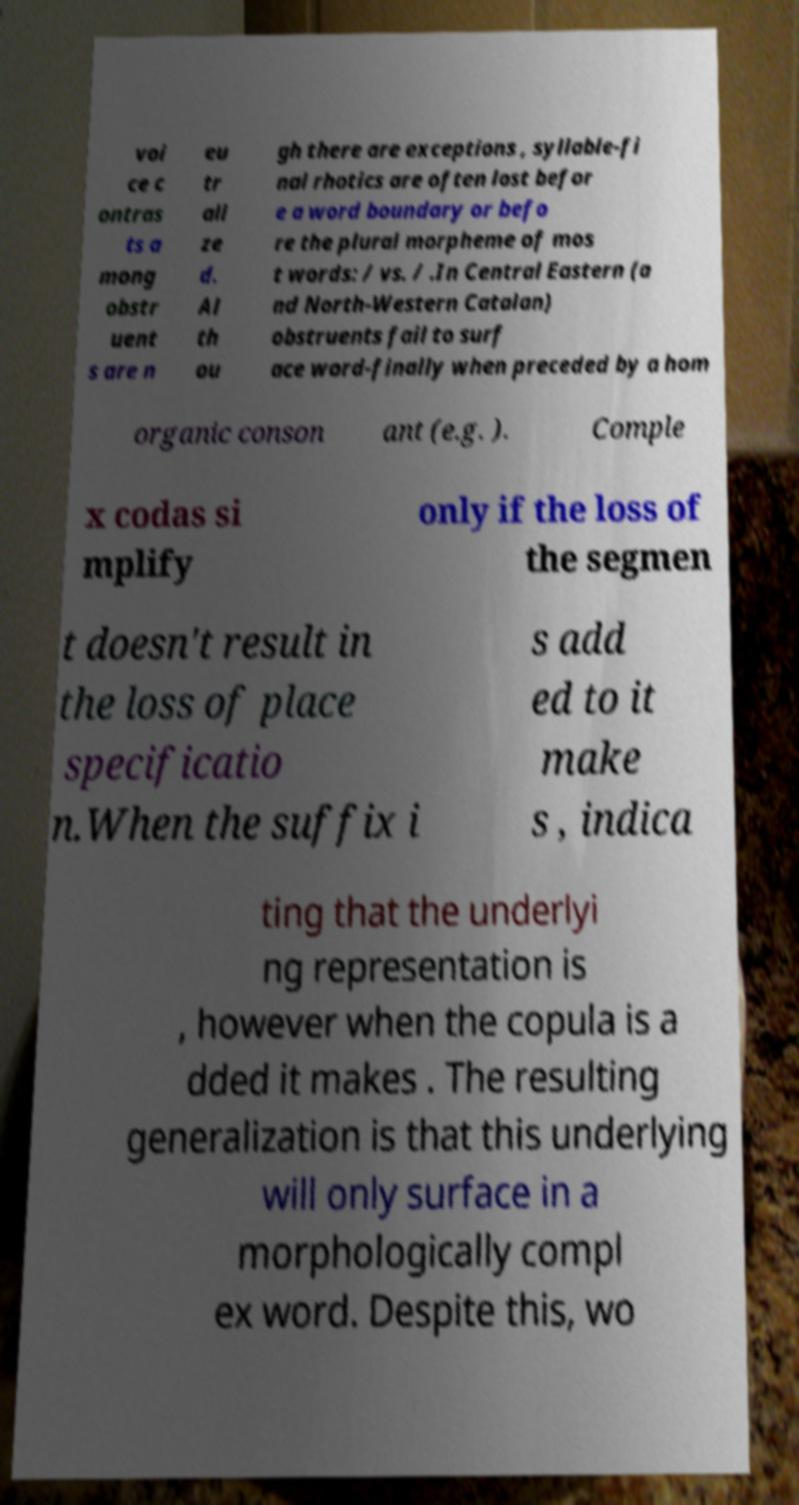For documentation purposes, I need the text within this image transcribed. Could you provide that? voi ce c ontras ts a mong obstr uent s are n eu tr ali ze d. Al th ou gh there are exceptions , syllable-fi nal rhotics are often lost befor e a word boundary or befo re the plural morpheme of mos t words: / vs. / .In Central Eastern (a nd North-Western Catalan) obstruents fail to surf ace word-finally when preceded by a hom organic conson ant (e.g. ). Comple x codas si mplify only if the loss of the segmen t doesn't result in the loss of place specificatio n.When the suffix i s add ed to it make s , indica ting that the underlyi ng representation is , however when the copula is a dded it makes . The resulting generalization is that this underlying will only surface in a morphologically compl ex word. Despite this, wo 